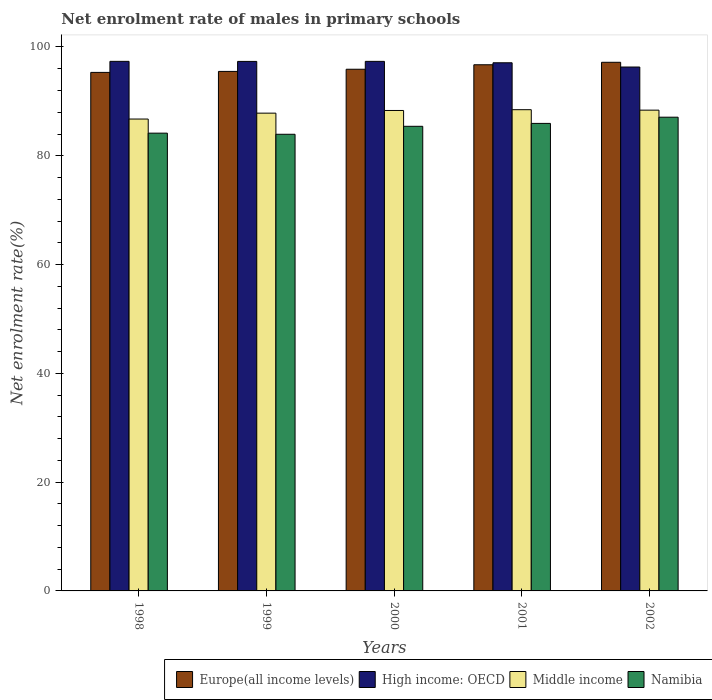How many different coloured bars are there?
Keep it short and to the point. 4. What is the label of the 3rd group of bars from the left?
Provide a short and direct response. 2000. What is the net enrolment rate of males in primary schools in Middle income in 2000?
Offer a very short reply. 88.33. Across all years, what is the maximum net enrolment rate of males in primary schools in Europe(all income levels)?
Your response must be concise. 97.19. Across all years, what is the minimum net enrolment rate of males in primary schools in Namibia?
Provide a short and direct response. 83.95. In which year was the net enrolment rate of males in primary schools in Middle income maximum?
Your response must be concise. 2001. In which year was the net enrolment rate of males in primary schools in Middle income minimum?
Provide a short and direct response. 1998. What is the total net enrolment rate of males in primary schools in Namibia in the graph?
Your answer should be compact. 426.58. What is the difference between the net enrolment rate of males in primary schools in Namibia in 1999 and that in 2002?
Ensure brevity in your answer.  -3.14. What is the difference between the net enrolment rate of males in primary schools in Namibia in 2000 and the net enrolment rate of males in primary schools in Europe(all income levels) in 1999?
Offer a terse response. -10.09. What is the average net enrolment rate of males in primary schools in Namibia per year?
Offer a terse response. 85.32. In the year 2000, what is the difference between the net enrolment rate of males in primary schools in High income: OECD and net enrolment rate of males in primary schools in Europe(all income levels)?
Keep it short and to the point. 1.45. In how many years, is the net enrolment rate of males in primary schools in High income: OECD greater than 8 %?
Your response must be concise. 5. What is the ratio of the net enrolment rate of males in primary schools in Europe(all income levels) in 1998 to that in 2000?
Provide a succinct answer. 0.99. Is the net enrolment rate of males in primary schools in Middle income in 1998 less than that in 1999?
Give a very brief answer. Yes. What is the difference between the highest and the second highest net enrolment rate of males in primary schools in Namibia?
Your response must be concise. 1.14. What is the difference between the highest and the lowest net enrolment rate of males in primary schools in Europe(all income levels)?
Make the answer very short. 1.86. Is it the case that in every year, the sum of the net enrolment rate of males in primary schools in Europe(all income levels) and net enrolment rate of males in primary schools in Middle income is greater than the sum of net enrolment rate of males in primary schools in Namibia and net enrolment rate of males in primary schools in High income: OECD?
Your answer should be very brief. No. What does the 4th bar from the left in 1999 represents?
Your response must be concise. Namibia. What does the 4th bar from the right in 1998 represents?
Ensure brevity in your answer.  Europe(all income levels). Are all the bars in the graph horizontal?
Give a very brief answer. No. Are the values on the major ticks of Y-axis written in scientific E-notation?
Your response must be concise. No. Does the graph contain grids?
Make the answer very short. No. How many legend labels are there?
Provide a short and direct response. 4. What is the title of the graph?
Keep it short and to the point. Net enrolment rate of males in primary schools. What is the label or title of the Y-axis?
Your answer should be very brief. Net enrolment rate(%). What is the Net enrolment rate(%) of Europe(all income levels) in 1998?
Your response must be concise. 95.33. What is the Net enrolment rate(%) of High income: OECD in 1998?
Provide a short and direct response. 97.36. What is the Net enrolment rate(%) of Middle income in 1998?
Offer a very short reply. 86.75. What is the Net enrolment rate(%) of Namibia in 1998?
Ensure brevity in your answer.  84.16. What is the Net enrolment rate(%) of Europe(all income levels) in 1999?
Offer a terse response. 95.51. What is the Net enrolment rate(%) of High income: OECD in 1999?
Give a very brief answer. 97.35. What is the Net enrolment rate(%) in Middle income in 1999?
Keep it short and to the point. 87.84. What is the Net enrolment rate(%) in Namibia in 1999?
Provide a succinct answer. 83.95. What is the Net enrolment rate(%) of Europe(all income levels) in 2000?
Your answer should be compact. 95.91. What is the Net enrolment rate(%) of High income: OECD in 2000?
Ensure brevity in your answer.  97.36. What is the Net enrolment rate(%) of Middle income in 2000?
Your answer should be compact. 88.33. What is the Net enrolment rate(%) of Namibia in 2000?
Your response must be concise. 85.42. What is the Net enrolment rate(%) of Europe(all income levels) in 2001?
Keep it short and to the point. 96.74. What is the Net enrolment rate(%) in High income: OECD in 2001?
Give a very brief answer. 97.1. What is the Net enrolment rate(%) of Middle income in 2001?
Provide a short and direct response. 88.47. What is the Net enrolment rate(%) in Namibia in 2001?
Provide a succinct answer. 85.95. What is the Net enrolment rate(%) in Europe(all income levels) in 2002?
Ensure brevity in your answer.  97.19. What is the Net enrolment rate(%) of High income: OECD in 2002?
Make the answer very short. 96.32. What is the Net enrolment rate(%) in Middle income in 2002?
Your response must be concise. 88.39. What is the Net enrolment rate(%) in Namibia in 2002?
Offer a very short reply. 87.09. Across all years, what is the maximum Net enrolment rate(%) of Europe(all income levels)?
Your answer should be compact. 97.19. Across all years, what is the maximum Net enrolment rate(%) in High income: OECD?
Your response must be concise. 97.36. Across all years, what is the maximum Net enrolment rate(%) of Middle income?
Provide a short and direct response. 88.47. Across all years, what is the maximum Net enrolment rate(%) in Namibia?
Offer a very short reply. 87.09. Across all years, what is the minimum Net enrolment rate(%) of Europe(all income levels)?
Ensure brevity in your answer.  95.33. Across all years, what is the minimum Net enrolment rate(%) in High income: OECD?
Your answer should be compact. 96.32. Across all years, what is the minimum Net enrolment rate(%) in Middle income?
Ensure brevity in your answer.  86.75. Across all years, what is the minimum Net enrolment rate(%) of Namibia?
Keep it short and to the point. 83.95. What is the total Net enrolment rate(%) of Europe(all income levels) in the graph?
Make the answer very short. 480.67. What is the total Net enrolment rate(%) of High income: OECD in the graph?
Offer a very short reply. 485.49. What is the total Net enrolment rate(%) in Middle income in the graph?
Ensure brevity in your answer.  439.78. What is the total Net enrolment rate(%) of Namibia in the graph?
Offer a very short reply. 426.58. What is the difference between the Net enrolment rate(%) in Europe(all income levels) in 1998 and that in 1999?
Offer a very short reply. -0.18. What is the difference between the Net enrolment rate(%) in High income: OECD in 1998 and that in 1999?
Provide a short and direct response. 0.01. What is the difference between the Net enrolment rate(%) in Middle income in 1998 and that in 1999?
Your answer should be compact. -1.08. What is the difference between the Net enrolment rate(%) of Namibia in 1998 and that in 1999?
Make the answer very short. 0.21. What is the difference between the Net enrolment rate(%) in Europe(all income levels) in 1998 and that in 2000?
Make the answer very short. -0.58. What is the difference between the Net enrolment rate(%) in High income: OECD in 1998 and that in 2000?
Offer a very short reply. 0. What is the difference between the Net enrolment rate(%) in Middle income in 1998 and that in 2000?
Provide a short and direct response. -1.58. What is the difference between the Net enrolment rate(%) of Namibia in 1998 and that in 2000?
Provide a succinct answer. -1.26. What is the difference between the Net enrolment rate(%) in Europe(all income levels) in 1998 and that in 2001?
Offer a very short reply. -1.41. What is the difference between the Net enrolment rate(%) in High income: OECD in 1998 and that in 2001?
Your answer should be very brief. 0.26. What is the difference between the Net enrolment rate(%) of Middle income in 1998 and that in 2001?
Offer a terse response. -1.72. What is the difference between the Net enrolment rate(%) of Namibia in 1998 and that in 2001?
Make the answer very short. -1.79. What is the difference between the Net enrolment rate(%) in Europe(all income levels) in 1998 and that in 2002?
Give a very brief answer. -1.86. What is the difference between the Net enrolment rate(%) of High income: OECD in 1998 and that in 2002?
Provide a short and direct response. 1.04. What is the difference between the Net enrolment rate(%) in Middle income in 1998 and that in 2002?
Keep it short and to the point. -1.64. What is the difference between the Net enrolment rate(%) of Namibia in 1998 and that in 2002?
Offer a terse response. -2.93. What is the difference between the Net enrolment rate(%) in Europe(all income levels) in 1999 and that in 2000?
Your answer should be very brief. -0.4. What is the difference between the Net enrolment rate(%) of High income: OECD in 1999 and that in 2000?
Ensure brevity in your answer.  -0.01. What is the difference between the Net enrolment rate(%) in Middle income in 1999 and that in 2000?
Keep it short and to the point. -0.49. What is the difference between the Net enrolment rate(%) of Namibia in 1999 and that in 2000?
Your response must be concise. -1.47. What is the difference between the Net enrolment rate(%) of Europe(all income levels) in 1999 and that in 2001?
Offer a very short reply. -1.23. What is the difference between the Net enrolment rate(%) in High income: OECD in 1999 and that in 2001?
Offer a terse response. 0.25. What is the difference between the Net enrolment rate(%) of Middle income in 1999 and that in 2001?
Offer a terse response. -0.63. What is the difference between the Net enrolment rate(%) in Namibia in 1999 and that in 2001?
Keep it short and to the point. -2. What is the difference between the Net enrolment rate(%) of Europe(all income levels) in 1999 and that in 2002?
Your answer should be compact. -1.68. What is the difference between the Net enrolment rate(%) in High income: OECD in 1999 and that in 2002?
Offer a terse response. 1.03. What is the difference between the Net enrolment rate(%) in Middle income in 1999 and that in 2002?
Your answer should be compact. -0.55. What is the difference between the Net enrolment rate(%) in Namibia in 1999 and that in 2002?
Provide a short and direct response. -3.14. What is the difference between the Net enrolment rate(%) of Europe(all income levels) in 2000 and that in 2001?
Offer a terse response. -0.83. What is the difference between the Net enrolment rate(%) of High income: OECD in 2000 and that in 2001?
Your answer should be compact. 0.26. What is the difference between the Net enrolment rate(%) in Middle income in 2000 and that in 2001?
Provide a short and direct response. -0.14. What is the difference between the Net enrolment rate(%) of Namibia in 2000 and that in 2001?
Give a very brief answer. -0.53. What is the difference between the Net enrolment rate(%) of Europe(all income levels) in 2000 and that in 2002?
Your response must be concise. -1.28. What is the difference between the Net enrolment rate(%) of High income: OECD in 2000 and that in 2002?
Offer a terse response. 1.04. What is the difference between the Net enrolment rate(%) of Middle income in 2000 and that in 2002?
Provide a short and direct response. -0.06. What is the difference between the Net enrolment rate(%) of Namibia in 2000 and that in 2002?
Make the answer very short. -1.67. What is the difference between the Net enrolment rate(%) in Europe(all income levels) in 2001 and that in 2002?
Make the answer very short. -0.45. What is the difference between the Net enrolment rate(%) of High income: OECD in 2001 and that in 2002?
Offer a very short reply. 0.78. What is the difference between the Net enrolment rate(%) of Middle income in 2001 and that in 2002?
Offer a very short reply. 0.08. What is the difference between the Net enrolment rate(%) in Namibia in 2001 and that in 2002?
Your answer should be compact. -1.14. What is the difference between the Net enrolment rate(%) of Europe(all income levels) in 1998 and the Net enrolment rate(%) of High income: OECD in 1999?
Keep it short and to the point. -2.02. What is the difference between the Net enrolment rate(%) of Europe(all income levels) in 1998 and the Net enrolment rate(%) of Middle income in 1999?
Offer a terse response. 7.49. What is the difference between the Net enrolment rate(%) in Europe(all income levels) in 1998 and the Net enrolment rate(%) in Namibia in 1999?
Offer a very short reply. 11.37. What is the difference between the Net enrolment rate(%) in High income: OECD in 1998 and the Net enrolment rate(%) in Middle income in 1999?
Provide a succinct answer. 9.52. What is the difference between the Net enrolment rate(%) of High income: OECD in 1998 and the Net enrolment rate(%) of Namibia in 1999?
Your answer should be compact. 13.41. What is the difference between the Net enrolment rate(%) in Middle income in 1998 and the Net enrolment rate(%) in Namibia in 1999?
Give a very brief answer. 2.8. What is the difference between the Net enrolment rate(%) in Europe(all income levels) in 1998 and the Net enrolment rate(%) in High income: OECD in 2000?
Provide a succinct answer. -2.03. What is the difference between the Net enrolment rate(%) of Europe(all income levels) in 1998 and the Net enrolment rate(%) of Middle income in 2000?
Offer a very short reply. 7. What is the difference between the Net enrolment rate(%) of Europe(all income levels) in 1998 and the Net enrolment rate(%) of Namibia in 2000?
Offer a terse response. 9.91. What is the difference between the Net enrolment rate(%) of High income: OECD in 1998 and the Net enrolment rate(%) of Middle income in 2000?
Your answer should be very brief. 9.03. What is the difference between the Net enrolment rate(%) of High income: OECD in 1998 and the Net enrolment rate(%) of Namibia in 2000?
Offer a very short reply. 11.94. What is the difference between the Net enrolment rate(%) in Europe(all income levels) in 1998 and the Net enrolment rate(%) in High income: OECD in 2001?
Offer a very short reply. -1.77. What is the difference between the Net enrolment rate(%) in Europe(all income levels) in 1998 and the Net enrolment rate(%) in Middle income in 2001?
Offer a very short reply. 6.86. What is the difference between the Net enrolment rate(%) in Europe(all income levels) in 1998 and the Net enrolment rate(%) in Namibia in 2001?
Your response must be concise. 9.37. What is the difference between the Net enrolment rate(%) of High income: OECD in 1998 and the Net enrolment rate(%) of Middle income in 2001?
Your answer should be very brief. 8.89. What is the difference between the Net enrolment rate(%) in High income: OECD in 1998 and the Net enrolment rate(%) in Namibia in 2001?
Offer a very short reply. 11.41. What is the difference between the Net enrolment rate(%) in Middle income in 1998 and the Net enrolment rate(%) in Namibia in 2001?
Offer a very short reply. 0.8. What is the difference between the Net enrolment rate(%) of Europe(all income levels) in 1998 and the Net enrolment rate(%) of High income: OECD in 2002?
Your answer should be very brief. -0.99. What is the difference between the Net enrolment rate(%) in Europe(all income levels) in 1998 and the Net enrolment rate(%) in Middle income in 2002?
Your answer should be very brief. 6.94. What is the difference between the Net enrolment rate(%) of Europe(all income levels) in 1998 and the Net enrolment rate(%) of Namibia in 2002?
Ensure brevity in your answer.  8.24. What is the difference between the Net enrolment rate(%) in High income: OECD in 1998 and the Net enrolment rate(%) in Middle income in 2002?
Your answer should be compact. 8.97. What is the difference between the Net enrolment rate(%) of High income: OECD in 1998 and the Net enrolment rate(%) of Namibia in 2002?
Offer a very short reply. 10.27. What is the difference between the Net enrolment rate(%) in Middle income in 1998 and the Net enrolment rate(%) in Namibia in 2002?
Offer a terse response. -0.34. What is the difference between the Net enrolment rate(%) in Europe(all income levels) in 1999 and the Net enrolment rate(%) in High income: OECD in 2000?
Offer a very short reply. -1.85. What is the difference between the Net enrolment rate(%) in Europe(all income levels) in 1999 and the Net enrolment rate(%) in Middle income in 2000?
Provide a short and direct response. 7.18. What is the difference between the Net enrolment rate(%) of Europe(all income levels) in 1999 and the Net enrolment rate(%) of Namibia in 2000?
Your answer should be very brief. 10.09. What is the difference between the Net enrolment rate(%) in High income: OECD in 1999 and the Net enrolment rate(%) in Middle income in 2000?
Provide a succinct answer. 9.02. What is the difference between the Net enrolment rate(%) of High income: OECD in 1999 and the Net enrolment rate(%) of Namibia in 2000?
Your answer should be very brief. 11.93. What is the difference between the Net enrolment rate(%) of Middle income in 1999 and the Net enrolment rate(%) of Namibia in 2000?
Offer a terse response. 2.42. What is the difference between the Net enrolment rate(%) of Europe(all income levels) in 1999 and the Net enrolment rate(%) of High income: OECD in 2001?
Give a very brief answer. -1.59. What is the difference between the Net enrolment rate(%) of Europe(all income levels) in 1999 and the Net enrolment rate(%) of Middle income in 2001?
Make the answer very short. 7.04. What is the difference between the Net enrolment rate(%) in Europe(all income levels) in 1999 and the Net enrolment rate(%) in Namibia in 2001?
Give a very brief answer. 9.56. What is the difference between the Net enrolment rate(%) in High income: OECD in 1999 and the Net enrolment rate(%) in Middle income in 2001?
Ensure brevity in your answer.  8.88. What is the difference between the Net enrolment rate(%) of High income: OECD in 1999 and the Net enrolment rate(%) of Namibia in 2001?
Ensure brevity in your answer.  11.4. What is the difference between the Net enrolment rate(%) in Middle income in 1999 and the Net enrolment rate(%) in Namibia in 2001?
Your answer should be very brief. 1.88. What is the difference between the Net enrolment rate(%) in Europe(all income levels) in 1999 and the Net enrolment rate(%) in High income: OECD in 2002?
Provide a succinct answer. -0.81. What is the difference between the Net enrolment rate(%) in Europe(all income levels) in 1999 and the Net enrolment rate(%) in Middle income in 2002?
Keep it short and to the point. 7.12. What is the difference between the Net enrolment rate(%) in Europe(all income levels) in 1999 and the Net enrolment rate(%) in Namibia in 2002?
Your answer should be very brief. 8.42. What is the difference between the Net enrolment rate(%) of High income: OECD in 1999 and the Net enrolment rate(%) of Middle income in 2002?
Give a very brief answer. 8.96. What is the difference between the Net enrolment rate(%) of High income: OECD in 1999 and the Net enrolment rate(%) of Namibia in 2002?
Your answer should be compact. 10.26. What is the difference between the Net enrolment rate(%) in Middle income in 1999 and the Net enrolment rate(%) in Namibia in 2002?
Make the answer very short. 0.75. What is the difference between the Net enrolment rate(%) of Europe(all income levels) in 2000 and the Net enrolment rate(%) of High income: OECD in 2001?
Give a very brief answer. -1.19. What is the difference between the Net enrolment rate(%) in Europe(all income levels) in 2000 and the Net enrolment rate(%) in Middle income in 2001?
Provide a short and direct response. 7.44. What is the difference between the Net enrolment rate(%) of Europe(all income levels) in 2000 and the Net enrolment rate(%) of Namibia in 2001?
Your answer should be very brief. 9.96. What is the difference between the Net enrolment rate(%) in High income: OECD in 2000 and the Net enrolment rate(%) in Middle income in 2001?
Provide a short and direct response. 8.89. What is the difference between the Net enrolment rate(%) in High income: OECD in 2000 and the Net enrolment rate(%) in Namibia in 2001?
Your answer should be compact. 11.4. What is the difference between the Net enrolment rate(%) in Middle income in 2000 and the Net enrolment rate(%) in Namibia in 2001?
Make the answer very short. 2.38. What is the difference between the Net enrolment rate(%) in Europe(all income levels) in 2000 and the Net enrolment rate(%) in High income: OECD in 2002?
Provide a short and direct response. -0.41. What is the difference between the Net enrolment rate(%) in Europe(all income levels) in 2000 and the Net enrolment rate(%) in Middle income in 2002?
Offer a terse response. 7.52. What is the difference between the Net enrolment rate(%) in Europe(all income levels) in 2000 and the Net enrolment rate(%) in Namibia in 2002?
Offer a very short reply. 8.82. What is the difference between the Net enrolment rate(%) of High income: OECD in 2000 and the Net enrolment rate(%) of Middle income in 2002?
Your response must be concise. 8.97. What is the difference between the Net enrolment rate(%) in High income: OECD in 2000 and the Net enrolment rate(%) in Namibia in 2002?
Your answer should be compact. 10.27. What is the difference between the Net enrolment rate(%) of Middle income in 2000 and the Net enrolment rate(%) of Namibia in 2002?
Your response must be concise. 1.24. What is the difference between the Net enrolment rate(%) of Europe(all income levels) in 2001 and the Net enrolment rate(%) of High income: OECD in 2002?
Offer a terse response. 0.42. What is the difference between the Net enrolment rate(%) of Europe(all income levels) in 2001 and the Net enrolment rate(%) of Middle income in 2002?
Your answer should be very brief. 8.35. What is the difference between the Net enrolment rate(%) of Europe(all income levels) in 2001 and the Net enrolment rate(%) of Namibia in 2002?
Your answer should be compact. 9.64. What is the difference between the Net enrolment rate(%) in High income: OECD in 2001 and the Net enrolment rate(%) in Middle income in 2002?
Keep it short and to the point. 8.71. What is the difference between the Net enrolment rate(%) of High income: OECD in 2001 and the Net enrolment rate(%) of Namibia in 2002?
Your answer should be compact. 10.01. What is the difference between the Net enrolment rate(%) in Middle income in 2001 and the Net enrolment rate(%) in Namibia in 2002?
Provide a short and direct response. 1.38. What is the average Net enrolment rate(%) in Europe(all income levels) per year?
Provide a short and direct response. 96.13. What is the average Net enrolment rate(%) of High income: OECD per year?
Offer a terse response. 97.1. What is the average Net enrolment rate(%) in Middle income per year?
Keep it short and to the point. 87.96. What is the average Net enrolment rate(%) of Namibia per year?
Provide a short and direct response. 85.32. In the year 1998, what is the difference between the Net enrolment rate(%) of Europe(all income levels) and Net enrolment rate(%) of High income: OECD?
Your answer should be very brief. -2.03. In the year 1998, what is the difference between the Net enrolment rate(%) of Europe(all income levels) and Net enrolment rate(%) of Middle income?
Provide a short and direct response. 8.58. In the year 1998, what is the difference between the Net enrolment rate(%) in Europe(all income levels) and Net enrolment rate(%) in Namibia?
Your answer should be very brief. 11.17. In the year 1998, what is the difference between the Net enrolment rate(%) of High income: OECD and Net enrolment rate(%) of Middle income?
Offer a terse response. 10.61. In the year 1998, what is the difference between the Net enrolment rate(%) of High income: OECD and Net enrolment rate(%) of Namibia?
Your response must be concise. 13.2. In the year 1998, what is the difference between the Net enrolment rate(%) in Middle income and Net enrolment rate(%) in Namibia?
Your response must be concise. 2.59. In the year 1999, what is the difference between the Net enrolment rate(%) in Europe(all income levels) and Net enrolment rate(%) in High income: OECD?
Provide a succinct answer. -1.84. In the year 1999, what is the difference between the Net enrolment rate(%) of Europe(all income levels) and Net enrolment rate(%) of Middle income?
Ensure brevity in your answer.  7.67. In the year 1999, what is the difference between the Net enrolment rate(%) in Europe(all income levels) and Net enrolment rate(%) in Namibia?
Your answer should be very brief. 11.56. In the year 1999, what is the difference between the Net enrolment rate(%) in High income: OECD and Net enrolment rate(%) in Middle income?
Provide a succinct answer. 9.51. In the year 1999, what is the difference between the Net enrolment rate(%) in High income: OECD and Net enrolment rate(%) in Namibia?
Provide a short and direct response. 13.4. In the year 1999, what is the difference between the Net enrolment rate(%) of Middle income and Net enrolment rate(%) of Namibia?
Offer a very short reply. 3.88. In the year 2000, what is the difference between the Net enrolment rate(%) in Europe(all income levels) and Net enrolment rate(%) in High income: OECD?
Keep it short and to the point. -1.45. In the year 2000, what is the difference between the Net enrolment rate(%) in Europe(all income levels) and Net enrolment rate(%) in Middle income?
Keep it short and to the point. 7.58. In the year 2000, what is the difference between the Net enrolment rate(%) of Europe(all income levels) and Net enrolment rate(%) of Namibia?
Offer a very short reply. 10.49. In the year 2000, what is the difference between the Net enrolment rate(%) of High income: OECD and Net enrolment rate(%) of Middle income?
Your answer should be very brief. 9.03. In the year 2000, what is the difference between the Net enrolment rate(%) in High income: OECD and Net enrolment rate(%) in Namibia?
Your answer should be very brief. 11.94. In the year 2000, what is the difference between the Net enrolment rate(%) of Middle income and Net enrolment rate(%) of Namibia?
Your answer should be compact. 2.91. In the year 2001, what is the difference between the Net enrolment rate(%) of Europe(all income levels) and Net enrolment rate(%) of High income: OECD?
Give a very brief answer. -0.36. In the year 2001, what is the difference between the Net enrolment rate(%) of Europe(all income levels) and Net enrolment rate(%) of Middle income?
Keep it short and to the point. 8.26. In the year 2001, what is the difference between the Net enrolment rate(%) in Europe(all income levels) and Net enrolment rate(%) in Namibia?
Offer a terse response. 10.78. In the year 2001, what is the difference between the Net enrolment rate(%) of High income: OECD and Net enrolment rate(%) of Middle income?
Offer a terse response. 8.63. In the year 2001, what is the difference between the Net enrolment rate(%) of High income: OECD and Net enrolment rate(%) of Namibia?
Provide a short and direct response. 11.15. In the year 2001, what is the difference between the Net enrolment rate(%) of Middle income and Net enrolment rate(%) of Namibia?
Your answer should be very brief. 2.52. In the year 2002, what is the difference between the Net enrolment rate(%) of Europe(all income levels) and Net enrolment rate(%) of High income: OECD?
Your answer should be very brief. 0.87. In the year 2002, what is the difference between the Net enrolment rate(%) in Europe(all income levels) and Net enrolment rate(%) in Middle income?
Offer a very short reply. 8.8. In the year 2002, what is the difference between the Net enrolment rate(%) in Europe(all income levels) and Net enrolment rate(%) in Namibia?
Your response must be concise. 10.1. In the year 2002, what is the difference between the Net enrolment rate(%) of High income: OECD and Net enrolment rate(%) of Middle income?
Make the answer very short. 7.93. In the year 2002, what is the difference between the Net enrolment rate(%) of High income: OECD and Net enrolment rate(%) of Namibia?
Make the answer very short. 9.22. In the year 2002, what is the difference between the Net enrolment rate(%) in Middle income and Net enrolment rate(%) in Namibia?
Make the answer very short. 1.3. What is the ratio of the Net enrolment rate(%) in High income: OECD in 1998 to that in 1999?
Your response must be concise. 1. What is the ratio of the Net enrolment rate(%) of Middle income in 1998 to that in 1999?
Offer a terse response. 0.99. What is the ratio of the Net enrolment rate(%) in Europe(all income levels) in 1998 to that in 2000?
Make the answer very short. 0.99. What is the ratio of the Net enrolment rate(%) in Middle income in 1998 to that in 2000?
Provide a succinct answer. 0.98. What is the ratio of the Net enrolment rate(%) in Namibia in 1998 to that in 2000?
Provide a short and direct response. 0.99. What is the ratio of the Net enrolment rate(%) of Europe(all income levels) in 1998 to that in 2001?
Provide a succinct answer. 0.99. What is the ratio of the Net enrolment rate(%) of High income: OECD in 1998 to that in 2001?
Provide a succinct answer. 1. What is the ratio of the Net enrolment rate(%) of Middle income in 1998 to that in 2001?
Make the answer very short. 0.98. What is the ratio of the Net enrolment rate(%) in Namibia in 1998 to that in 2001?
Your answer should be very brief. 0.98. What is the ratio of the Net enrolment rate(%) in Europe(all income levels) in 1998 to that in 2002?
Make the answer very short. 0.98. What is the ratio of the Net enrolment rate(%) in High income: OECD in 1998 to that in 2002?
Your answer should be compact. 1.01. What is the ratio of the Net enrolment rate(%) in Middle income in 1998 to that in 2002?
Give a very brief answer. 0.98. What is the ratio of the Net enrolment rate(%) of Namibia in 1998 to that in 2002?
Offer a terse response. 0.97. What is the ratio of the Net enrolment rate(%) in High income: OECD in 1999 to that in 2000?
Offer a terse response. 1. What is the ratio of the Net enrolment rate(%) in Middle income in 1999 to that in 2000?
Ensure brevity in your answer.  0.99. What is the ratio of the Net enrolment rate(%) of Namibia in 1999 to that in 2000?
Provide a succinct answer. 0.98. What is the ratio of the Net enrolment rate(%) in Europe(all income levels) in 1999 to that in 2001?
Make the answer very short. 0.99. What is the ratio of the Net enrolment rate(%) of High income: OECD in 1999 to that in 2001?
Give a very brief answer. 1. What is the ratio of the Net enrolment rate(%) in Middle income in 1999 to that in 2001?
Offer a terse response. 0.99. What is the ratio of the Net enrolment rate(%) in Namibia in 1999 to that in 2001?
Keep it short and to the point. 0.98. What is the ratio of the Net enrolment rate(%) in Europe(all income levels) in 1999 to that in 2002?
Offer a terse response. 0.98. What is the ratio of the Net enrolment rate(%) of High income: OECD in 1999 to that in 2002?
Offer a terse response. 1.01. What is the ratio of the Net enrolment rate(%) of Middle income in 1999 to that in 2002?
Make the answer very short. 0.99. What is the ratio of the Net enrolment rate(%) in Namibia in 2000 to that in 2001?
Offer a very short reply. 0.99. What is the ratio of the Net enrolment rate(%) of Europe(all income levels) in 2000 to that in 2002?
Provide a succinct answer. 0.99. What is the ratio of the Net enrolment rate(%) in High income: OECD in 2000 to that in 2002?
Ensure brevity in your answer.  1.01. What is the ratio of the Net enrolment rate(%) of Namibia in 2000 to that in 2002?
Provide a short and direct response. 0.98. What is the ratio of the Net enrolment rate(%) of Europe(all income levels) in 2001 to that in 2002?
Provide a succinct answer. 1. What is the ratio of the Net enrolment rate(%) in Middle income in 2001 to that in 2002?
Make the answer very short. 1. What is the ratio of the Net enrolment rate(%) of Namibia in 2001 to that in 2002?
Keep it short and to the point. 0.99. What is the difference between the highest and the second highest Net enrolment rate(%) in Europe(all income levels)?
Provide a short and direct response. 0.45. What is the difference between the highest and the second highest Net enrolment rate(%) in High income: OECD?
Give a very brief answer. 0. What is the difference between the highest and the second highest Net enrolment rate(%) in Middle income?
Ensure brevity in your answer.  0.08. What is the difference between the highest and the second highest Net enrolment rate(%) in Namibia?
Your answer should be very brief. 1.14. What is the difference between the highest and the lowest Net enrolment rate(%) of Europe(all income levels)?
Provide a succinct answer. 1.86. What is the difference between the highest and the lowest Net enrolment rate(%) of High income: OECD?
Provide a succinct answer. 1.04. What is the difference between the highest and the lowest Net enrolment rate(%) of Middle income?
Give a very brief answer. 1.72. What is the difference between the highest and the lowest Net enrolment rate(%) in Namibia?
Offer a terse response. 3.14. 